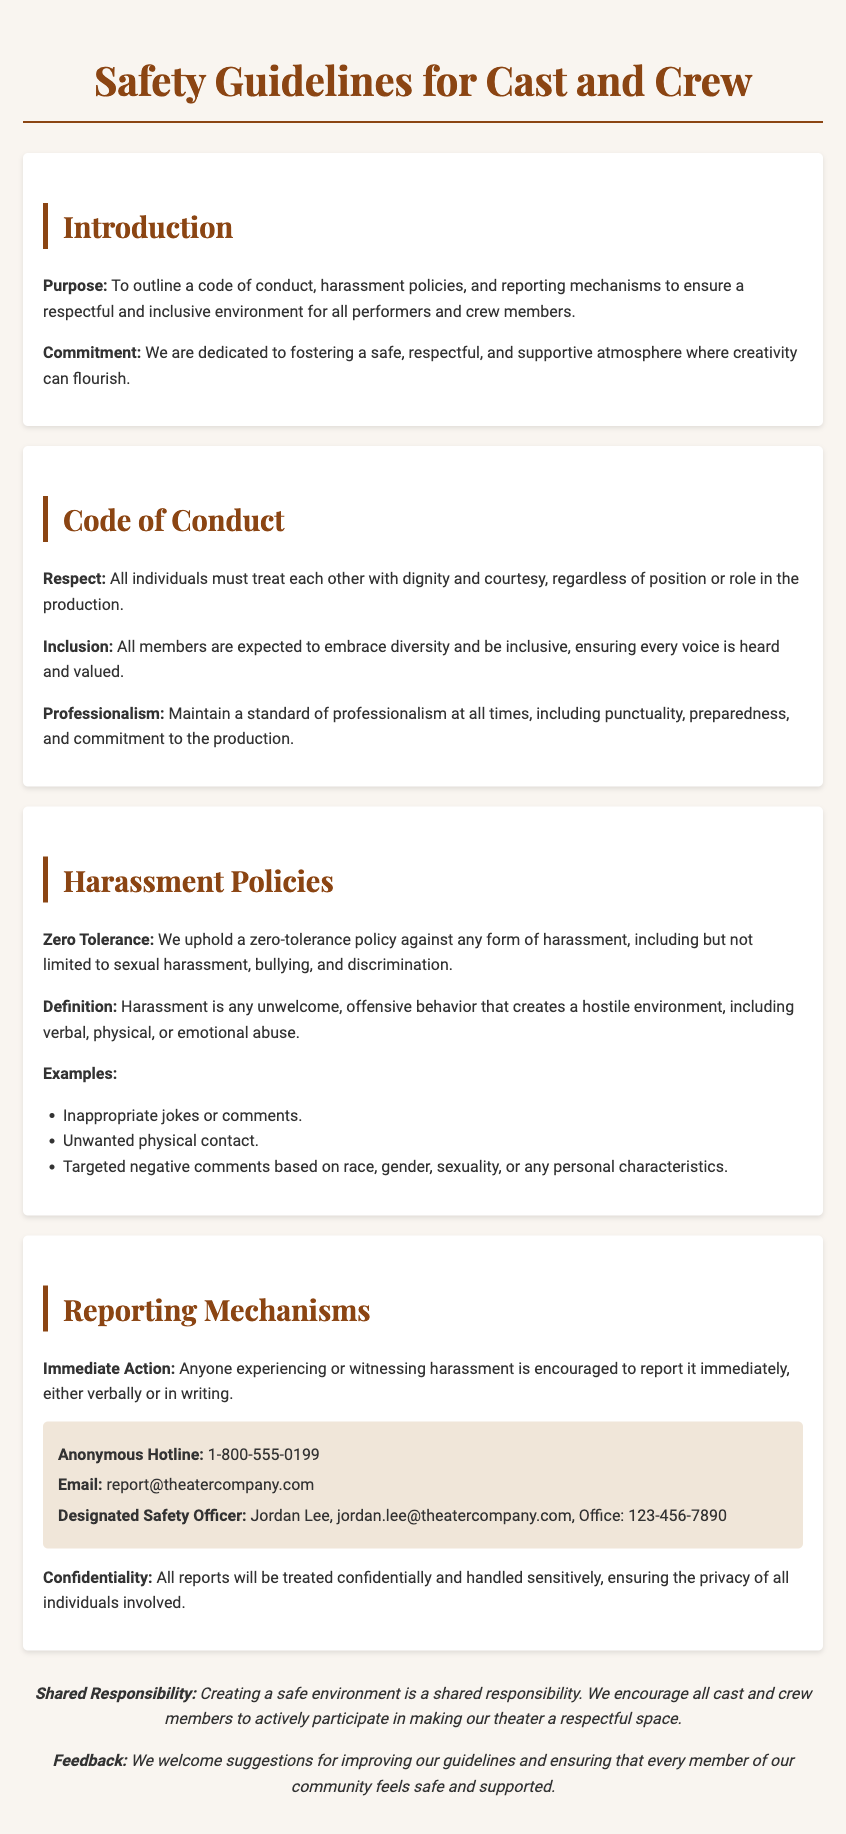what is the purpose of the manual? The purpose is to outline a code of conduct, harassment policies, and reporting mechanisms.
Answer: outline a code of conduct, harassment policies, and reporting mechanisms who is the designated safety officer? The designated safety officer is Jordan Lee.
Answer: Jordan Lee what is the reporting hotline number? The anonymous hotline number provided for reporting is 1-800-555-0199.
Answer: 1-800-555-0199 what does the manual state about harassment? The manual states a zero-tolerance policy against any form of harassment.
Answer: zero-tolerance policy what should a person do if they witness harassment? They are encouraged to report it immediately, either verbally or in writing.
Answer: report it immediately how many types of unwelcoming behavior are listed as examples of harassment? Three types of unwelcoming behaviors are given as examples in the manual.
Answer: Three what is emphasized as a shared responsibility? Creating a safe environment is emphasized as a shared responsibility.
Answer: creating a safe environment what type of atmosphere does the manual aim to foster? The manual aims to foster a safe, respectful, and supportive atmosphere.
Answer: safe, respectful, and supportive atmosphere 